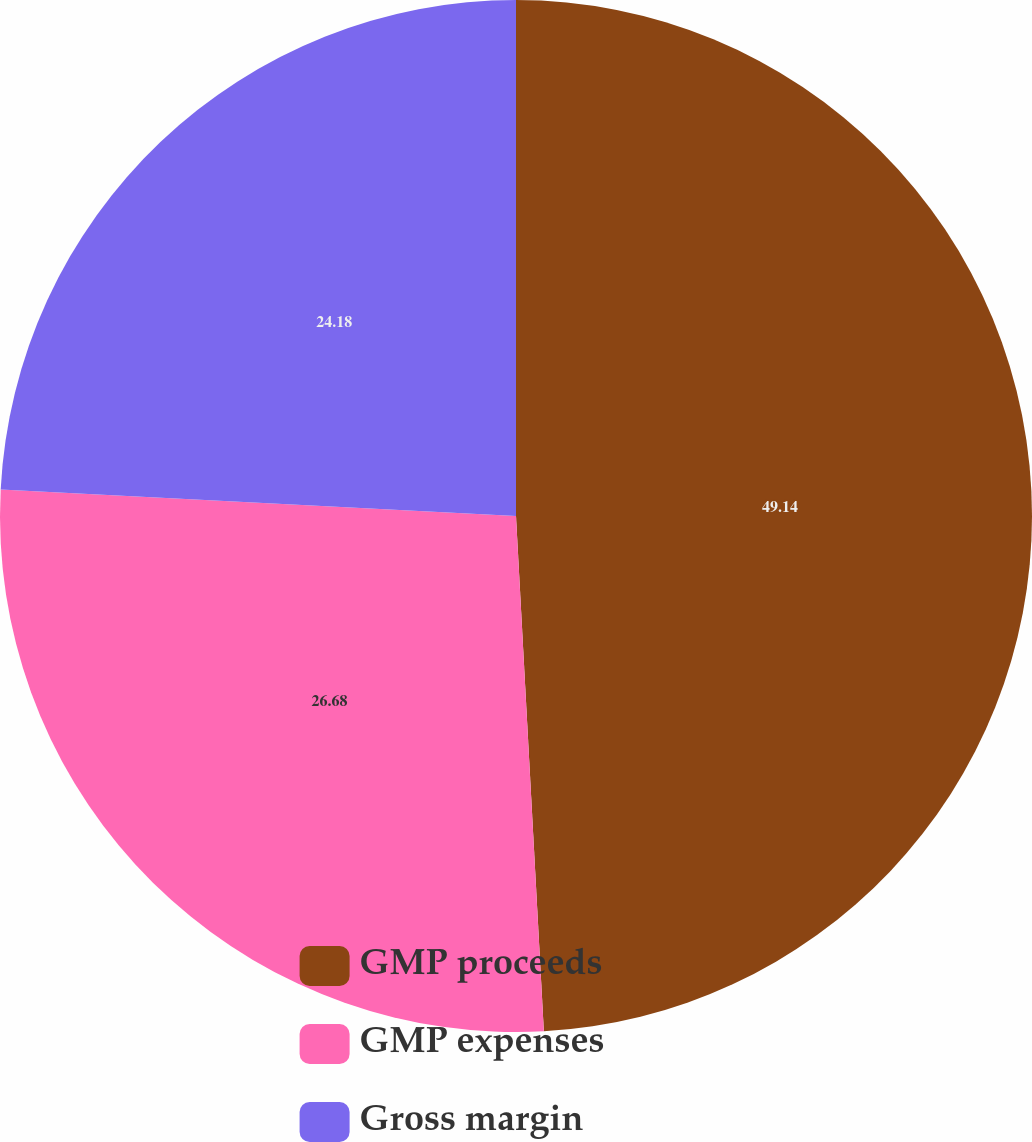Convert chart. <chart><loc_0><loc_0><loc_500><loc_500><pie_chart><fcel>GMP proceeds<fcel>GMP expenses<fcel>Gross margin<nl><fcel>49.14%<fcel>26.68%<fcel>24.18%<nl></chart> 